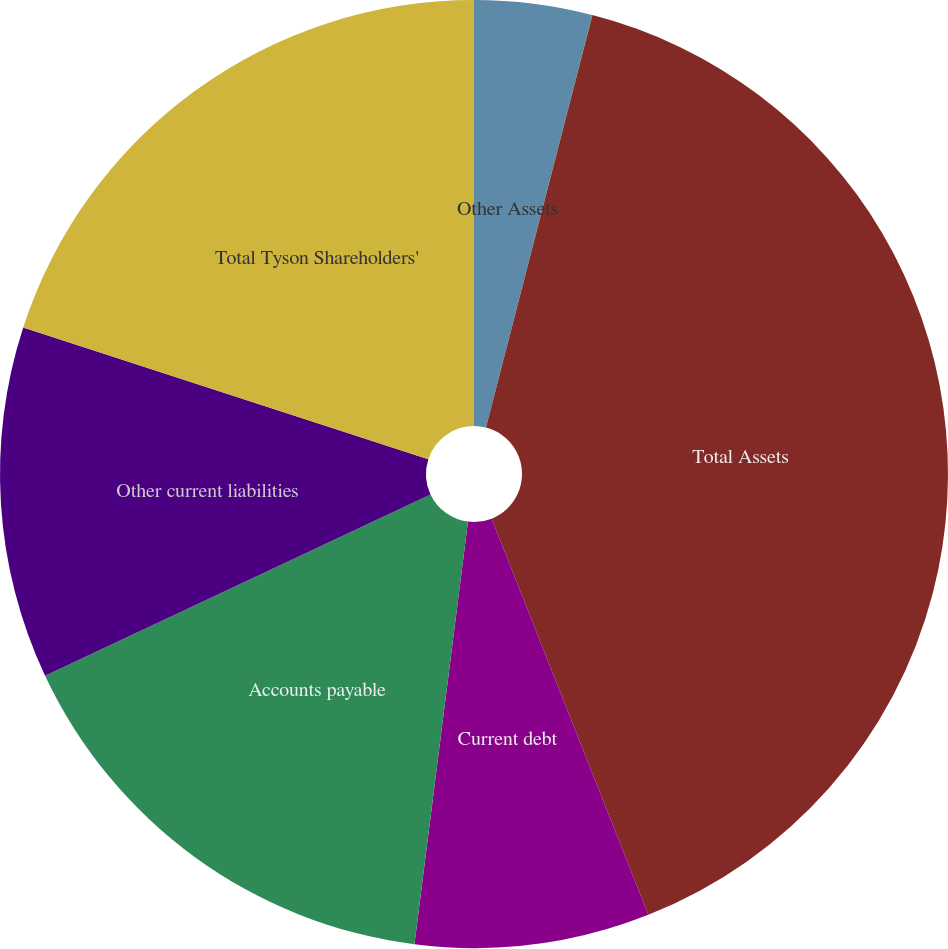Convert chart to OTSL. <chart><loc_0><loc_0><loc_500><loc_500><pie_chart><fcel>Other Assets<fcel>Investment in Subsidiaries<fcel>Total Assets<fcel>Current debt<fcel>Accounts payable<fcel>Other current liabilities<fcel>Total Tyson Shareholders'<nl><fcel>4.01%<fcel>0.01%<fcel>39.99%<fcel>8.0%<fcel>16.0%<fcel>12.0%<fcel>20.0%<nl></chart> 